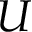Convert formula to latex. <formula><loc_0><loc_0><loc_500><loc_500>U</formula> 